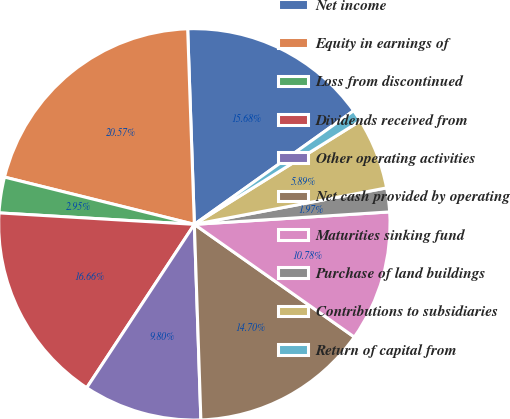Convert chart to OTSL. <chart><loc_0><loc_0><loc_500><loc_500><pie_chart><fcel>Net income<fcel>Equity in earnings of<fcel>Loss from discontinued<fcel>Dividends received from<fcel>Other operating activities<fcel>Net cash provided by operating<fcel>Maturities sinking fund<fcel>Purchase of land buildings<fcel>Contributions to subsidiaries<fcel>Return of capital from<nl><fcel>15.68%<fcel>20.57%<fcel>2.95%<fcel>16.66%<fcel>9.8%<fcel>14.7%<fcel>10.78%<fcel>1.97%<fcel>5.89%<fcel>0.99%<nl></chart> 